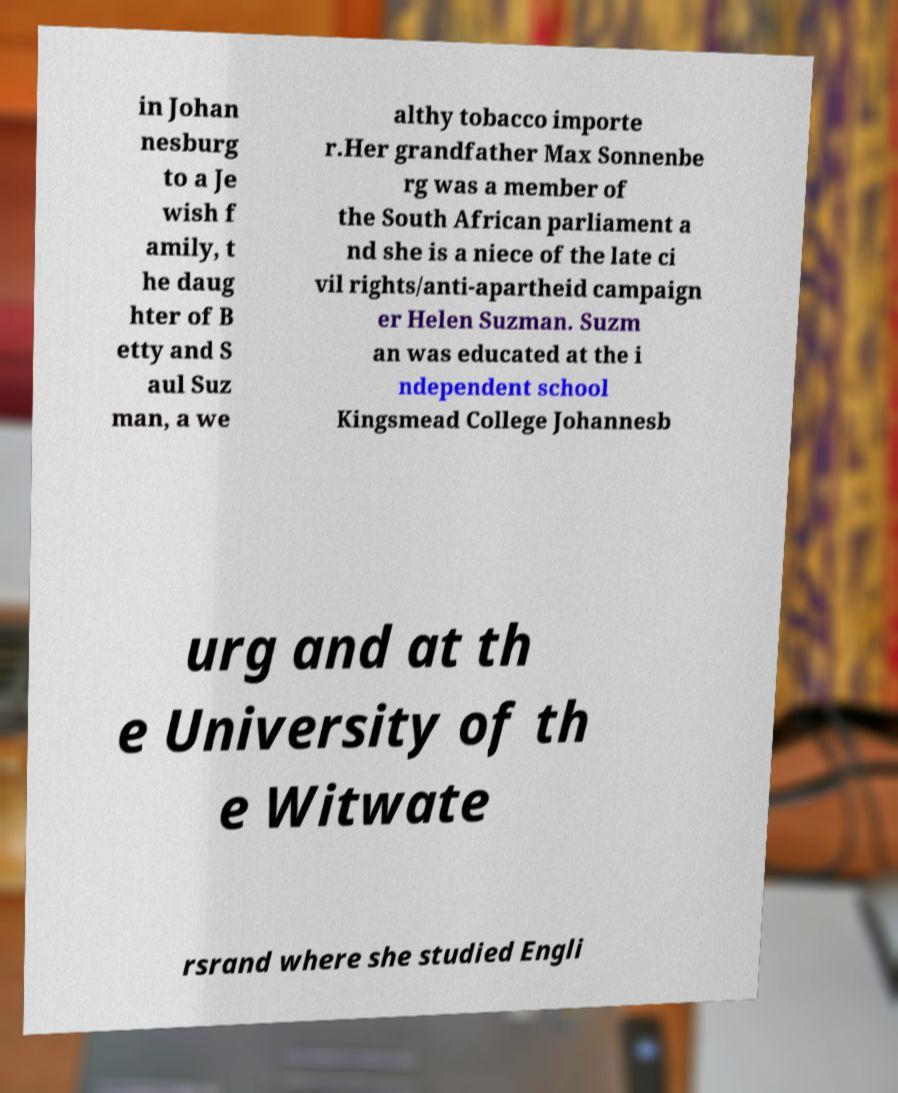Please read and relay the text visible in this image. What does it say? in Johan nesburg to a Je wish f amily, t he daug hter of B etty and S aul Suz man, a we althy tobacco importe r.Her grandfather Max Sonnenbe rg was a member of the South African parliament a nd she is a niece of the late ci vil rights/anti-apartheid campaign er Helen Suzman. Suzm an was educated at the i ndependent school Kingsmead College Johannesb urg and at th e University of th e Witwate rsrand where she studied Engli 